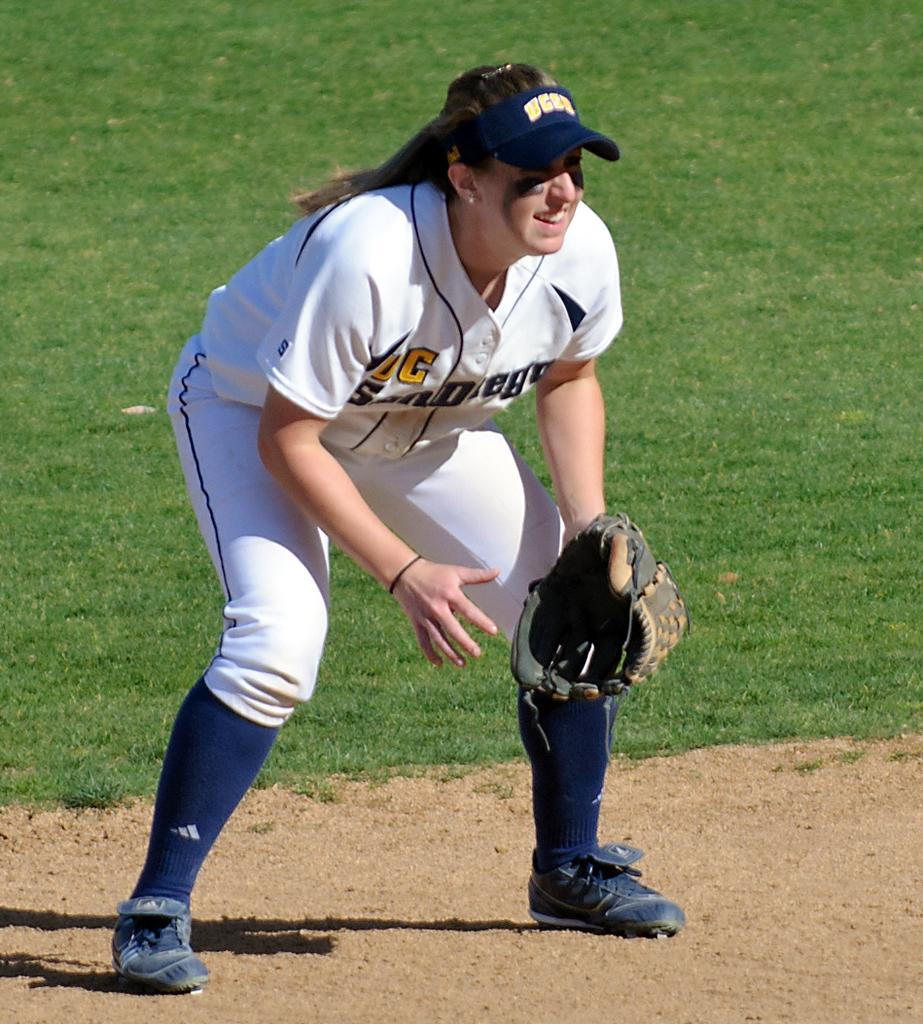<image>
Share a concise interpretation of the image provided. A female baseball player that has a visible G on her uniform. 